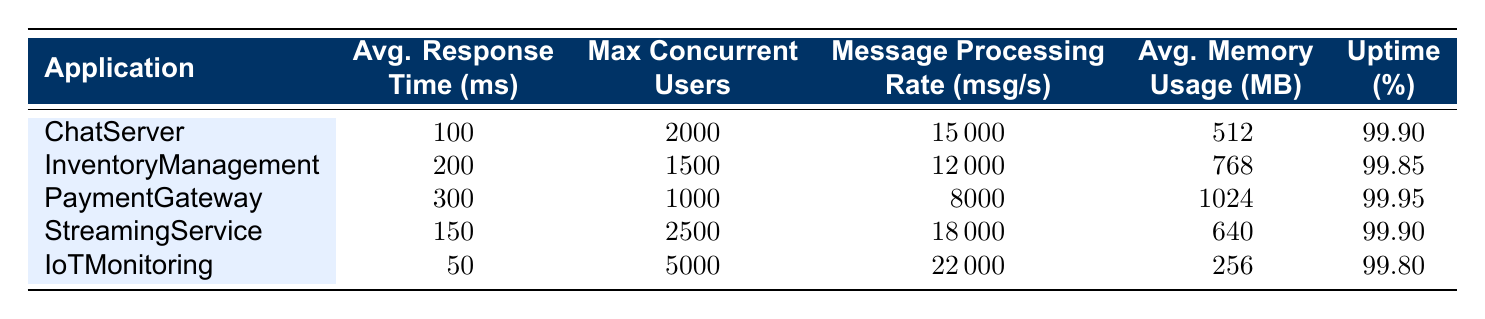What is the average response time for the StreamingService application? The average response time for the StreamingService application is listed in the table as 150 ms under the average response time column.
Answer: 150 ms How many maximum concurrent users can the IoTMonitoring application handle? The IoTMonitoring application has a maximum concurrent user capacity of 5000, as indicated in the corresponding row of the table.
Answer: 5000 Which application has the highest average memory usage? By comparing the average memory usage values across all applications, PaymentGateway has the highest usage at 1024 MB.
Answer: PaymentGateway What is the total message processing rate of ChatServer and StreamingService combined? The message processing rate for ChatServer is 15000 msg/s and for StreamingService is 18000 msg/s. Adding these together gives: 15000 + 18000 = 33000 msg/s.
Answer: 33000 msg/s Is the uptime percentage for InventoryManagement higher than that for PaymentGateway? The uptime percentage for InventoryManagement is 99.85% and for PaymentGateway it is 99.95%. Since 99.85% is less than 99.95%, this statement is false.
Answer: No Which application has the lowest average response time, and by how much is it lower than PaymentGateway? The IoTMonitoring application has the lowest average response time at 50 ms. PaymentGateway has an average response time of 300 ms. The difference is: 300 - 50 = 250 ms.
Answer: IoTMonitoring; 250 ms If the message processing rates for all applications were to be averaged, what would be the mean? The sum of the message processing rates is: (15000 + 12000 + 8000 + 18000 + 22000) = 75000 msg/s. There are 5 applications, so the average is: 75000 / 5 = 15000 msg/s.
Answer: 15000 msg/s Is it true that the average memory usage of the ChatServer is less than that of the InventoryManagement application? The average memory usage for ChatServer is 512 MB and for InventoryManagement is 768 MB. Since 512 MB is less than 768 MB, this statement is true.
Answer: Yes What is the difference in maximum concurrent users between StreamingService and PaymentGateway? StreamingService can handle 2500 users while PaymentGateway can handle 1000 users. The difference is: 2500 - 1000 = 1500 users.
Answer: 1500 users 